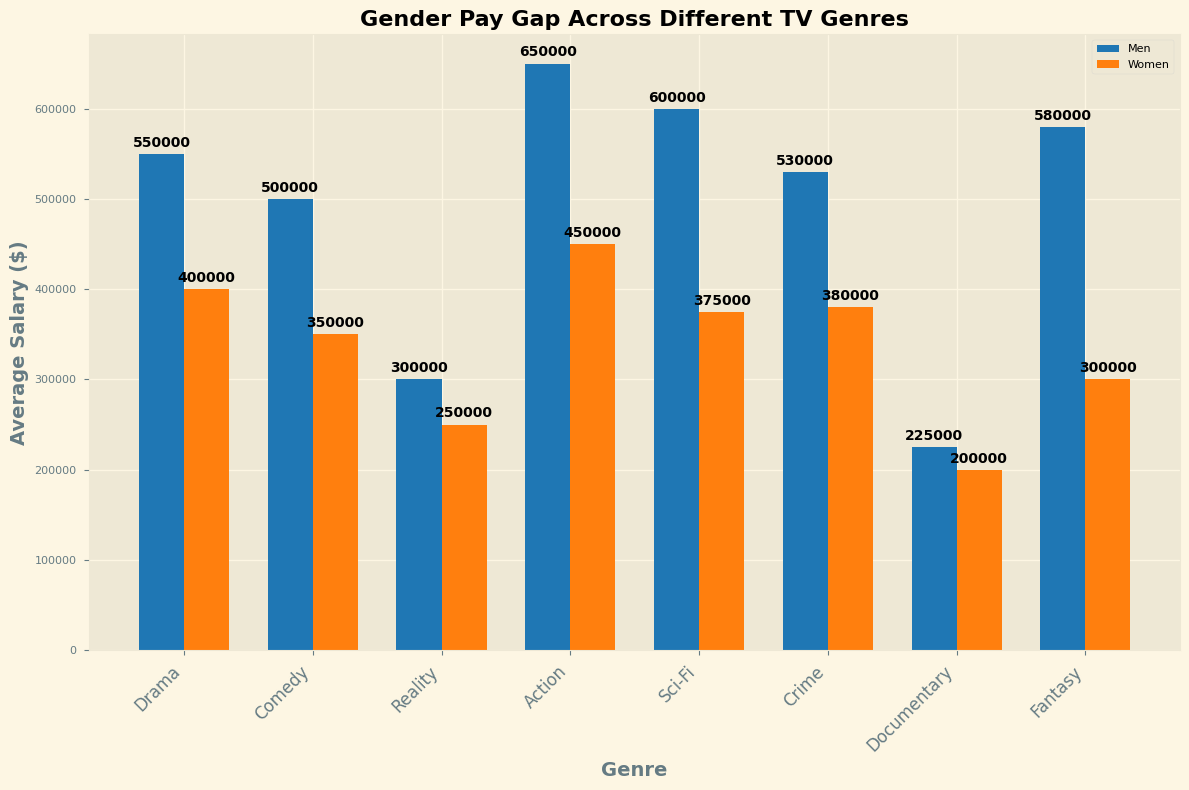What is the average salary difference between men and women in the Drama genre? The average salary for men in Drama is $550,000 and for women, it is $400,000. The difference is $550,000 - $400,000.
Answer: $150,000 Which genre shows the largest gender pay gap? To find the largest gender pay gap, compare the differences in average salaries for men and women across all genres. Drama has a $150,000 gap, Comedy has a $150,000 gap, Reality has a $50,000 gap, Action has a $200,000 gap, Sci-Fi has a $225,000 gap, Crime has a $150,000 gap, Documentary has a $25,000 gap, and Fantasy has a $280,000 gap. The largest gap is in Fantasy with $280,000.
Answer: Fantasy Which gender earns more in the Reality genre, and by how much? In the Reality genre, men earn an average salary of $300,000 and women earn $250,000. The difference is $300,000 - $250,000.
Answer: Men, $50,000 Compare the average salaries of men in Action and Sci-Fi genres. Which genre pays men more? In the Action genre, the average salary for men is $650,000, while in the Sci-Fi genre it is $600,000. $650,000 is greater than $600,000.
Answer: Action What is the combined average salary for women in the Comedy and Crime genres? The average salary for women in Comedy is $350,000 and in Crime it is $380,000. The combined average is $350,000 + $380,000.
Answer: $730,000 Identify the genre where women have the highest average salary. Compare the average salaries for women across all genres. Drama ($400,000), Comedy ($350,000), Reality ($250,000), Action ($450,000), Sci-Fi ($375,000), Crime ($380,000), Documentary ($200,000), Fantasy ($300,000). The highest average salary for women is in Action with $450,000.
Answer: Action How much more do men earn on average than women in the Sci-Fi genre? The average salary for men in Sci-Fi is $600,000 and for women, it is $375,000. The difference is $600,000 - $375,000.
Answer: $225,000 In which genre is the gender pay gap the smallest? To find the smallest gender pay gap, compare the differences in average salaries for men and women across all genres. Drama has a $150,000 gap, Comedy has a $150,000 gap, Reality has a $50,000 gap, Action has a $200,000 gap, Sci-Fi has a $225,000 gap, Crime has a $150,000 gap, Documentary has a $25,000 gap, and Fantasy has a $280,000 gap. The smallest gap is in Documentary with $25,000.
Answer: Documentary 